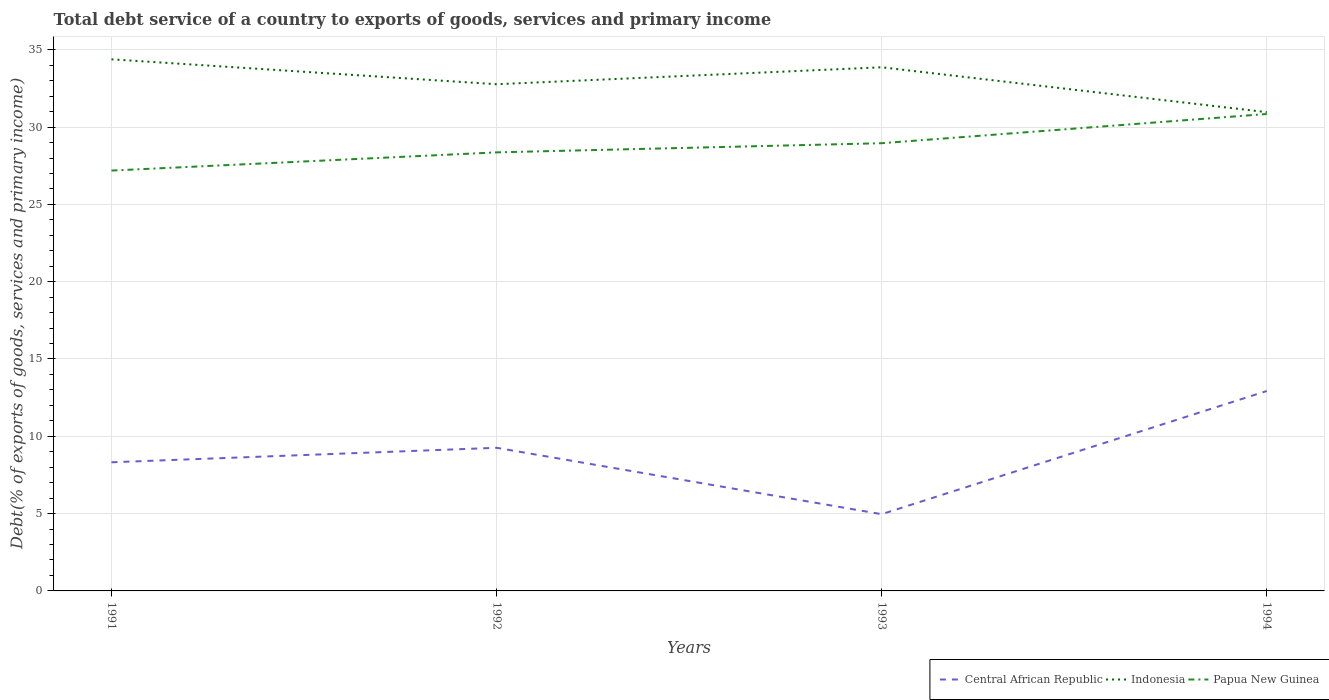Across all years, what is the maximum total debt service in Indonesia?
Provide a succinct answer. 30.96. In which year was the total debt service in Central African Republic maximum?
Give a very brief answer. 1993. What is the total total debt service in Indonesia in the graph?
Keep it short and to the point. 1.81. What is the difference between the highest and the second highest total debt service in Central African Republic?
Keep it short and to the point. 7.97. Is the total debt service in Indonesia strictly greater than the total debt service in Central African Republic over the years?
Provide a succinct answer. No. Where does the legend appear in the graph?
Ensure brevity in your answer.  Bottom right. How many legend labels are there?
Your response must be concise. 3. What is the title of the graph?
Offer a terse response. Total debt service of a country to exports of goods, services and primary income. Does "Latin America(developing only)" appear as one of the legend labels in the graph?
Your answer should be compact. No. What is the label or title of the X-axis?
Make the answer very short. Years. What is the label or title of the Y-axis?
Give a very brief answer. Debt(% of exports of goods, services and primary income). What is the Debt(% of exports of goods, services and primary income) in Central African Republic in 1991?
Give a very brief answer. 8.32. What is the Debt(% of exports of goods, services and primary income) in Indonesia in 1991?
Your answer should be very brief. 34.38. What is the Debt(% of exports of goods, services and primary income) in Papua New Guinea in 1991?
Keep it short and to the point. 27.19. What is the Debt(% of exports of goods, services and primary income) of Central African Republic in 1992?
Provide a short and direct response. 9.26. What is the Debt(% of exports of goods, services and primary income) in Indonesia in 1992?
Provide a succinct answer. 32.77. What is the Debt(% of exports of goods, services and primary income) of Papua New Guinea in 1992?
Your answer should be very brief. 28.36. What is the Debt(% of exports of goods, services and primary income) of Central African Republic in 1993?
Your answer should be very brief. 4.96. What is the Debt(% of exports of goods, services and primary income) in Indonesia in 1993?
Your answer should be very brief. 33.87. What is the Debt(% of exports of goods, services and primary income) of Papua New Guinea in 1993?
Offer a terse response. 28.96. What is the Debt(% of exports of goods, services and primary income) of Central African Republic in 1994?
Provide a succinct answer. 12.93. What is the Debt(% of exports of goods, services and primary income) in Indonesia in 1994?
Offer a terse response. 30.96. What is the Debt(% of exports of goods, services and primary income) in Papua New Guinea in 1994?
Give a very brief answer. 30.85. Across all years, what is the maximum Debt(% of exports of goods, services and primary income) in Central African Republic?
Provide a short and direct response. 12.93. Across all years, what is the maximum Debt(% of exports of goods, services and primary income) in Indonesia?
Keep it short and to the point. 34.38. Across all years, what is the maximum Debt(% of exports of goods, services and primary income) in Papua New Guinea?
Your answer should be compact. 30.85. Across all years, what is the minimum Debt(% of exports of goods, services and primary income) in Central African Republic?
Offer a very short reply. 4.96. Across all years, what is the minimum Debt(% of exports of goods, services and primary income) of Indonesia?
Offer a terse response. 30.96. Across all years, what is the minimum Debt(% of exports of goods, services and primary income) in Papua New Guinea?
Keep it short and to the point. 27.19. What is the total Debt(% of exports of goods, services and primary income) in Central African Republic in the graph?
Make the answer very short. 35.47. What is the total Debt(% of exports of goods, services and primary income) of Indonesia in the graph?
Ensure brevity in your answer.  131.99. What is the total Debt(% of exports of goods, services and primary income) of Papua New Guinea in the graph?
Your response must be concise. 115.35. What is the difference between the Debt(% of exports of goods, services and primary income) of Central African Republic in 1991 and that in 1992?
Ensure brevity in your answer.  -0.94. What is the difference between the Debt(% of exports of goods, services and primary income) of Indonesia in 1991 and that in 1992?
Your answer should be compact. 1.61. What is the difference between the Debt(% of exports of goods, services and primary income) of Papua New Guinea in 1991 and that in 1992?
Ensure brevity in your answer.  -1.18. What is the difference between the Debt(% of exports of goods, services and primary income) of Central African Republic in 1991 and that in 1993?
Make the answer very short. 3.36. What is the difference between the Debt(% of exports of goods, services and primary income) in Indonesia in 1991 and that in 1993?
Keep it short and to the point. 0.52. What is the difference between the Debt(% of exports of goods, services and primary income) of Papua New Guinea in 1991 and that in 1993?
Offer a terse response. -1.77. What is the difference between the Debt(% of exports of goods, services and primary income) of Central African Republic in 1991 and that in 1994?
Your response must be concise. -4.61. What is the difference between the Debt(% of exports of goods, services and primary income) of Indonesia in 1991 and that in 1994?
Offer a very short reply. 3.42. What is the difference between the Debt(% of exports of goods, services and primary income) of Papua New Guinea in 1991 and that in 1994?
Ensure brevity in your answer.  -3.66. What is the difference between the Debt(% of exports of goods, services and primary income) in Central African Republic in 1992 and that in 1993?
Ensure brevity in your answer.  4.29. What is the difference between the Debt(% of exports of goods, services and primary income) in Indonesia in 1992 and that in 1993?
Keep it short and to the point. -1.1. What is the difference between the Debt(% of exports of goods, services and primary income) of Papua New Guinea in 1992 and that in 1993?
Your answer should be very brief. -0.59. What is the difference between the Debt(% of exports of goods, services and primary income) of Central African Republic in 1992 and that in 1994?
Your response must be concise. -3.67. What is the difference between the Debt(% of exports of goods, services and primary income) in Indonesia in 1992 and that in 1994?
Ensure brevity in your answer.  1.81. What is the difference between the Debt(% of exports of goods, services and primary income) in Papua New Guinea in 1992 and that in 1994?
Your answer should be compact. -2.48. What is the difference between the Debt(% of exports of goods, services and primary income) in Central African Republic in 1993 and that in 1994?
Keep it short and to the point. -7.97. What is the difference between the Debt(% of exports of goods, services and primary income) in Indonesia in 1993 and that in 1994?
Ensure brevity in your answer.  2.9. What is the difference between the Debt(% of exports of goods, services and primary income) in Papua New Guinea in 1993 and that in 1994?
Your response must be concise. -1.89. What is the difference between the Debt(% of exports of goods, services and primary income) of Central African Republic in 1991 and the Debt(% of exports of goods, services and primary income) of Indonesia in 1992?
Your answer should be very brief. -24.45. What is the difference between the Debt(% of exports of goods, services and primary income) in Central African Republic in 1991 and the Debt(% of exports of goods, services and primary income) in Papua New Guinea in 1992?
Keep it short and to the point. -20.04. What is the difference between the Debt(% of exports of goods, services and primary income) in Indonesia in 1991 and the Debt(% of exports of goods, services and primary income) in Papua New Guinea in 1992?
Your answer should be compact. 6.02. What is the difference between the Debt(% of exports of goods, services and primary income) of Central African Republic in 1991 and the Debt(% of exports of goods, services and primary income) of Indonesia in 1993?
Make the answer very short. -25.55. What is the difference between the Debt(% of exports of goods, services and primary income) of Central African Republic in 1991 and the Debt(% of exports of goods, services and primary income) of Papua New Guinea in 1993?
Provide a short and direct response. -20.64. What is the difference between the Debt(% of exports of goods, services and primary income) of Indonesia in 1991 and the Debt(% of exports of goods, services and primary income) of Papua New Guinea in 1993?
Make the answer very short. 5.43. What is the difference between the Debt(% of exports of goods, services and primary income) in Central African Republic in 1991 and the Debt(% of exports of goods, services and primary income) in Indonesia in 1994?
Keep it short and to the point. -22.64. What is the difference between the Debt(% of exports of goods, services and primary income) of Central African Republic in 1991 and the Debt(% of exports of goods, services and primary income) of Papua New Guinea in 1994?
Your answer should be compact. -22.53. What is the difference between the Debt(% of exports of goods, services and primary income) in Indonesia in 1991 and the Debt(% of exports of goods, services and primary income) in Papua New Guinea in 1994?
Keep it short and to the point. 3.54. What is the difference between the Debt(% of exports of goods, services and primary income) of Central African Republic in 1992 and the Debt(% of exports of goods, services and primary income) of Indonesia in 1993?
Provide a succinct answer. -24.61. What is the difference between the Debt(% of exports of goods, services and primary income) in Central African Republic in 1992 and the Debt(% of exports of goods, services and primary income) in Papua New Guinea in 1993?
Provide a short and direct response. -19.7. What is the difference between the Debt(% of exports of goods, services and primary income) in Indonesia in 1992 and the Debt(% of exports of goods, services and primary income) in Papua New Guinea in 1993?
Offer a terse response. 3.81. What is the difference between the Debt(% of exports of goods, services and primary income) of Central African Republic in 1992 and the Debt(% of exports of goods, services and primary income) of Indonesia in 1994?
Provide a short and direct response. -21.71. What is the difference between the Debt(% of exports of goods, services and primary income) of Central African Republic in 1992 and the Debt(% of exports of goods, services and primary income) of Papua New Guinea in 1994?
Give a very brief answer. -21.59. What is the difference between the Debt(% of exports of goods, services and primary income) of Indonesia in 1992 and the Debt(% of exports of goods, services and primary income) of Papua New Guinea in 1994?
Your response must be concise. 1.93. What is the difference between the Debt(% of exports of goods, services and primary income) of Central African Republic in 1993 and the Debt(% of exports of goods, services and primary income) of Indonesia in 1994?
Your response must be concise. -26. What is the difference between the Debt(% of exports of goods, services and primary income) in Central African Republic in 1993 and the Debt(% of exports of goods, services and primary income) in Papua New Guinea in 1994?
Your response must be concise. -25.88. What is the difference between the Debt(% of exports of goods, services and primary income) of Indonesia in 1993 and the Debt(% of exports of goods, services and primary income) of Papua New Guinea in 1994?
Give a very brief answer. 3.02. What is the average Debt(% of exports of goods, services and primary income) of Central African Republic per year?
Provide a short and direct response. 8.87. What is the average Debt(% of exports of goods, services and primary income) in Indonesia per year?
Offer a very short reply. 33. What is the average Debt(% of exports of goods, services and primary income) of Papua New Guinea per year?
Provide a succinct answer. 28.84. In the year 1991, what is the difference between the Debt(% of exports of goods, services and primary income) in Central African Republic and Debt(% of exports of goods, services and primary income) in Indonesia?
Ensure brevity in your answer.  -26.06. In the year 1991, what is the difference between the Debt(% of exports of goods, services and primary income) in Central African Republic and Debt(% of exports of goods, services and primary income) in Papua New Guinea?
Your response must be concise. -18.87. In the year 1991, what is the difference between the Debt(% of exports of goods, services and primary income) of Indonesia and Debt(% of exports of goods, services and primary income) of Papua New Guinea?
Provide a succinct answer. 7.2. In the year 1992, what is the difference between the Debt(% of exports of goods, services and primary income) in Central African Republic and Debt(% of exports of goods, services and primary income) in Indonesia?
Provide a short and direct response. -23.51. In the year 1992, what is the difference between the Debt(% of exports of goods, services and primary income) of Central African Republic and Debt(% of exports of goods, services and primary income) of Papua New Guinea?
Keep it short and to the point. -19.11. In the year 1992, what is the difference between the Debt(% of exports of goods, services and primary income) in Indonesia and Debt(% of exports of goods, services and primary income) in Papua New Guinea?
Offer a terse response. 4.41. In the year 1993, what is the difference between the Debt(% of exports of goods, services and primary income) in Central African Republic and Debt(% of exports of goods, services and primary income) in Indonesia?
Ensure brevity in your answer.  -28.9. In the year 1993, what is the difference between the Debt(% of exports of goods, services and primary income) of Central African Republic and Debt(% of exports of goods, services and primary income) of Papua New Guinea?
Provide a short and direct response. -23.99. In the year 1993, what is the difference between the Debt(% of exports of goods, services and primary income) of Indonesia and Debt(% of exports of goods, services and primary income) of Papua New Guinea?
Offer a terse response. 4.91. In the year 1994, what is the difference between the Debt(% of exports of goods, services and primary income) in Central African Republic and Debt(% of exports of goods, services and primary income) in Indonesia?
Keep it short and to the point. -18.04. In the year 1994, what is the difference between the Debt(% of exports of goods, services and primary income) in Central African Republic and Debt(% of exports of goods, services and primary income) in Papua New Guinea?
Ensure brevity in your answer.  -17.92. In the year 1994, what is the difference between the Debt(% of exports of goods, services and primary income) in Indonesia and Debt(% of exports of goods, services and primary income) in Papua New Guinea?
Offer a very short reply. 0.12. What is the ratio of the Debt(% of exports of goods, services and primary income) of Central African Republic in 1991 to that in 1992?
Keep it short and to the point. 0.9. What is the ratio of the Debt(% of exports of goods, services and primary income) in Indonesia in 1991 to that in 1992?
Ensure brevity in your answer.  1.05. What is the ratio of the Debt(% of exports of goods, services and primary income) in Papua New Guinea in 1991 to that in 1992?
Ensure brevity in your answer.  0.96. What is the ratio of the Debt(% of exports of goods, services and primary income) in Central African Republic in 1991 to that in 1993?
Your response must be concise. 1.68. What is the ratio of the Debt(% of exports of goods, services and primary income) of Indonesia in 1991 to that in 1993?
Your response must be concise. 1.02. What is the ratio of the Debt(% of exports of goods, services and primary income) in Papua New Guinea in 1991 to that in 1993?
Your response must be concise. 0.94. What is the ratio of the Debt(% of exports of goods, services and primary income) of Central African Republic in 1991 to that in 1994?
Your answer should be compact. 0.64. What is the ratio of the Debt(% of exports of goods, services and primary income) of Indonesia in 1991 to that in 1994?
Offer a terse response. 1.11. What is the ratio of the Debt(% of exports of goods, services and primary income) of Papua New Guinea in 1991 to that in 1994?
Your response must be concise. 0.88. What is the ratio of the Debt(% of exports of goods, services and primary income) of Central African Republic in 1992 to that in 1993?
Your answer should be compact. 1.87. What is the ratio of the Debt(% of exports of goods, services and primary income) of Indonesia in 1992 to that in 1993?
Offer a terse response. 0.97. What is the ratio of the Debt(% of exports of goods, services and primary income) in Papua New Guinea in 1992 to that in 1993?
Make the answer very short. 0.98. What is the ratio of the Debt(% of exports of goods, services and primary income) of Central African Republic in 1992 to that in 1994?
Ensure brevity in your answer.  0.72. What is the ratio of the Debt(% of exports of goods, services and primary income) in Indonesia in 1992 to that in 1994?
Your answer should be compact. 1.06. What is the ratio of the Debt(% of exports of goods, services and primary income) in Papua New Guinea in 1992 to that in 1994?
Your answer should be very brief. 0.92. What is the ratio of the Debt(% of exports of goods, services and primary income) in Central African Republic in 1993 to that in 1994?
Provide a short and direct response. 0.38. What is the ratio of the Debt(% of exports of goods, services and primary income) of Indonesia in 1993 to that in 1994?
Ensure brevity in your answer.  1.09. What is the ratio of the Debt(% of exports of goods, services and primary income) of Papua New Guinea in 1993 to that in 1994?
Your answer should be compact. 0.94. What is the difference between the highest and the second highest Debt(% of exports of goods, services and primary income) in Central African Republic?
Provide a short and direct response. 3.67. What is the difference between the highest and the second highest Debt(% of exports of goods, services and primary income) of Indonesia?
Ensure brevity in your answer.  0.52. What is the difference between the highest and the second highest Debt(% of exports of goods, services and primary income) in Papua New Guinea?
Ensure brevity in your answer.  1.89. What is the difference between the highest and the lowest Debt(% of exports of goods, services and primary income) of Central African Republic?
Your answer should be very brief. 7.97. What is the difference between the highest and the lowest Debt(% of exports of goods, services and primary income) in Indonesia?
Provide a succinct answer. 3.42. What is the difference between the highest and the lowest Debt(% of exports of goods, services and primary income) of Papua New Guinea?
Ensure brevity in your answer.  3.66. 